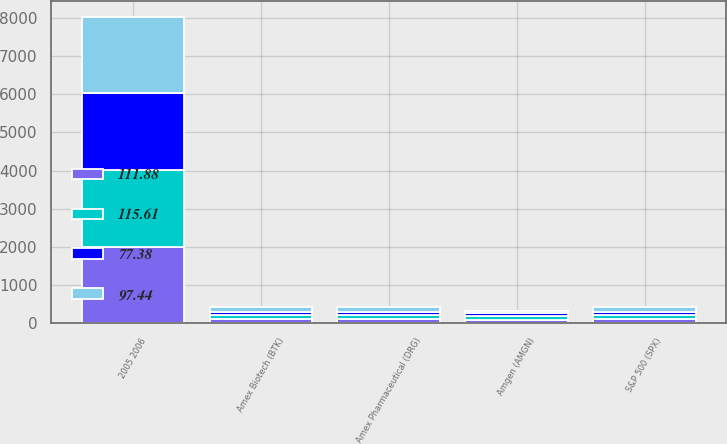Convert chart. <chart><loc_0><loc_0><loc_500><loc_500><stacked_bar_chart><ecel><fcel>2005 2006<fcel>Amgen (AMGN)<fcel>Amex Biotech (BTK)<fcel>Amex Pharmaceutical (DRG)<fcel>S&P 500 (SPX)<nl><fcel>115.61<fcel>2007<fcel>100<fcel>100<fcel>100<fcel>100<nl><fcel>111.88<fcel>2008<fcel>86.62<fcel>110.77<fcel>110.59<fcel>115.61<nl><fcel>97.44<fcel>2008<fcel>58.89<fcel>115.51<fcel>111.71<fcel>121.95<nl><fcel>77.38<fcel>2009<fcel>73.23<fcel>95.05<fcel>93.74<fcel>77.38<nl></chart> 